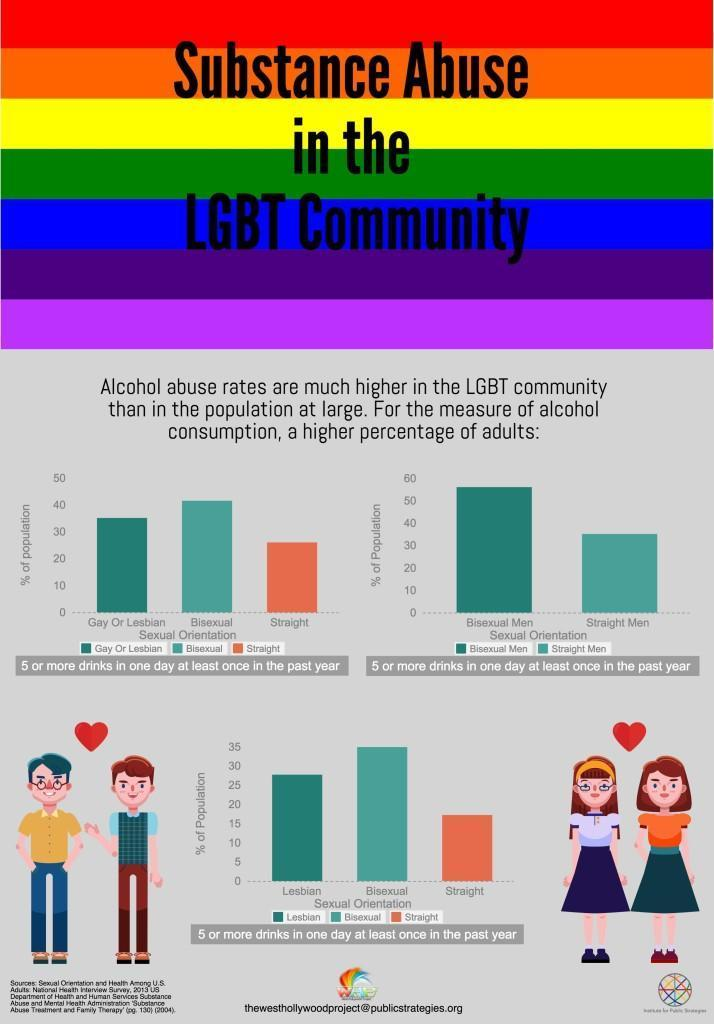Specify some key components in this picture. There is no evidence to suggest that alcohol consumption is higher in bisexual individuals compared to straight individuals. 